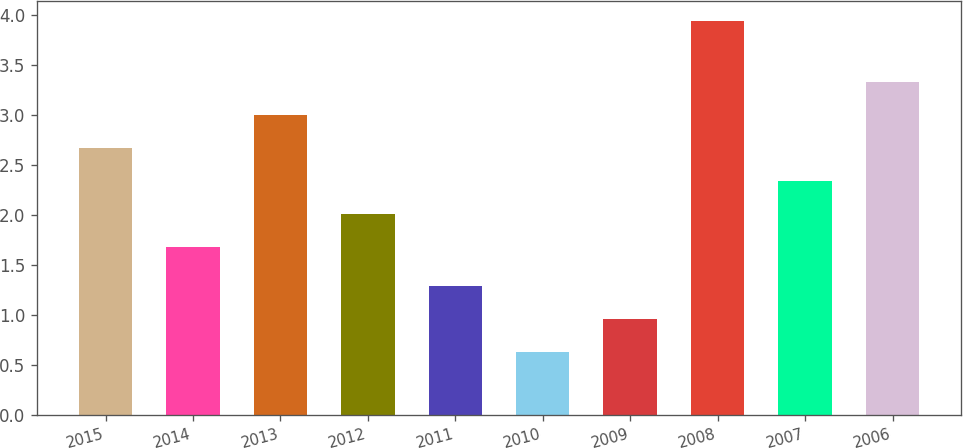<chart> <loc_0><loc_0><loc_500><loc_500><bar_chart><fcel>2015<fcel>2014<fcel>2013<fcel>2012<fcel>2011<fcel>2010<fcel>2009<fcel>2008<fcel>2007<fcel>2006<nl><fcel>2.67<fcel>1.68<fcel>3<fcel>2.01<fcel>1.29<fcel>0.63<fcel>0.96<fcel>3.94<fcel>2.34<fcel>3.33<nl></chart> 